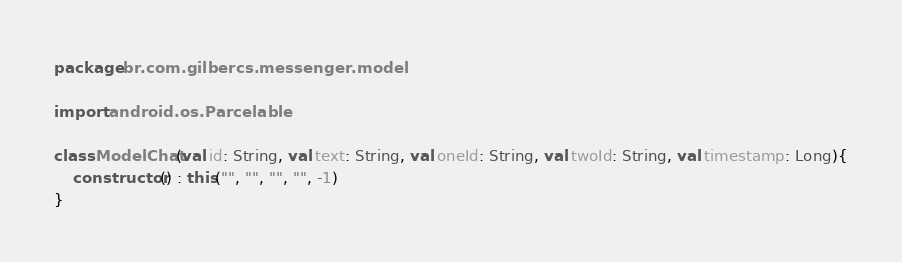Convert code to text. <code><loc_0><loc_0><loc_500><loc_500><_Kotlin_>package br.com.gilbercs.messenger.model

import android.os.Parcelable

class ModelChat(val id: String, val text: String, val oneId: String, val twoId: String, val timestamp: Long){
    constructor() : this("", "", "", "", -1)
}</code> 